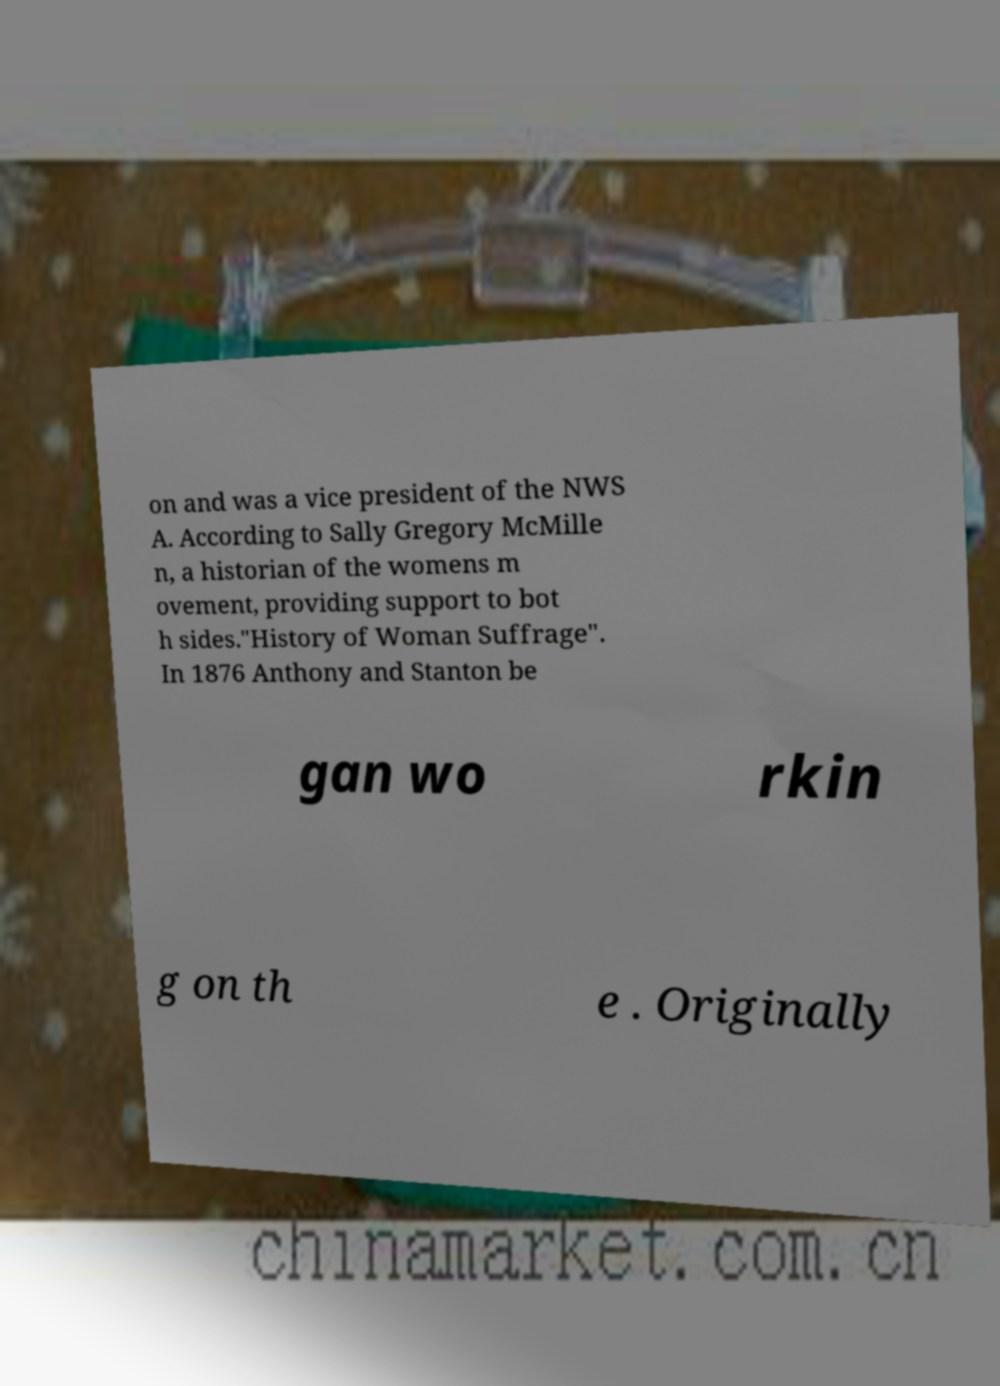Can you read and provide the text displayed in the image?This photo seems to have some interesting text. Can you extract and type it out for me? on and was a vice president of the NWS A. According to Sally Gregory McMille n, a historian of the womens m ovement, providing support to bot h sides."History of Woman Suffrage". In 1876 Anthony and Stanton be gan wo rkin g on th e . Originally 